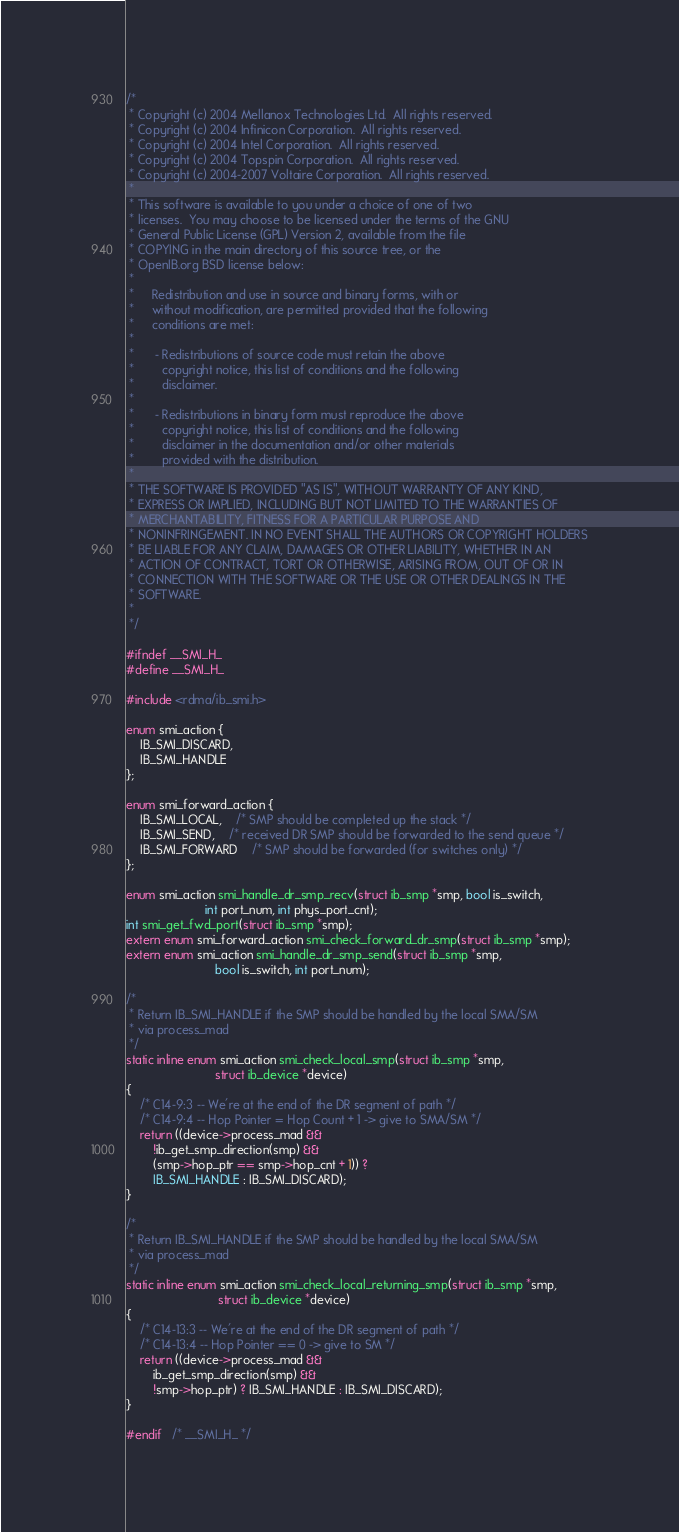Convert code to text. <code><loc_0><loc_0><loc_500><loc_500><_C_>/*
 * Copyright (c) 2004 Mellanox Technologies Ltd.  All rights reserved.
 * Copyright (c) 2004 Infinicon Corporation.  All rights reserved.
 * Copyright (c) 2004 Intel Corporation.  All rights reserved.
 * Copyright (c) 2004 Topspin Corporation.  All rights reserved.
 * Copyright (c) 2004-2007 Voltaire Corporation.  All rights reserved.
 *
 * This software is available to you under a choice of one of two
 * licenses.  You may choose to be licensed under the terms of the GNU
 * General Public License (GPL) Version 2, available from the file
 * COPYING in the main directory of this source tree, or the
 * OpenIB.org BSD license below:
 *
 *     Redistribution and use in source and binary forms, with or
 *     without modification, are permitted provided that the following
 *     conditions are met:
 *
 *      - Redistributions of source code must retain the above
 *        copyright notice, this list of conditions and the following
 *        disclaimer.
 *
 *      - Redistributions in binary form must reproduce the above
 *        copyright notice, this list of conditions and the following
 *        disclaimer in the documentation and/or other materials
 *        provided with the distribution.
 *
 * THE SOFTWARE IS PROVIDED "AS IS", WITHOUT WARRANTY OF ANY KIND,
 * EXPRESS OR IMPLIED, INCLUDING BUT NOT LIMITED TO THE WARRANTIES OF
 * MERCHANTABILITY, FITNESS FOR A PARTICULAR PURPOSE AND
 * NONINFRINGEMENT. IN NO EVENT SHALL THE AUTHORS OR COPYRIGHT HOLDERS
 * BE LIABLE FOR ANY CLAIM, DAMAGES OR OTHER LIABILITY, WHETHER IN AN
 * ACTION OF CONTRACT, TORT OR OTHERWISE, ARISING FROM, OUT OF OR IN
 * CONNECTION WITH THE SOFTWARE OR THE USE OR OTHER DEALINGS IN THE
 * SOFTWARE.
 *
 */

#ifndef __SMI_H_
#define __SMI_H_

#include <rdma/ib_smi.h>

enum smi_action {
	IB_SMI_DISCARD,
	IB_SMI_HANDLE
};

enum smi_forward_action {
	IB_SMI_LOCAL,	/* SMP should be completed up the stack */
	IB_SMI_SEND,	/* received DR SMP should be forwarded to the send queue */
	IB_SMI_FORWARD	/* SMP should be forwarded (for switches only) */
};

enum smi_action smi_handle_dr_smp_recv(struct ib_smp *smp, bool is_switch,
				       int port_num, int phys_port_cnt);
int smi_get_fwd_port(struct ib_smp *smp);
extern enum smi_forward_action smi_check_forward_dr_smp(struct ib_smp *smp);
extern enum smi_action smi_handle_dr_smp_send(struct ib_smp *smp,
					      bool is_switch, int port_num);

/*
 * Return IB_SMI_HANDLE if the SMP should be handled by the local SMA/SM
 * via process_mad
 */
static inline enum smi_action smi_check_local_smp(struct ib_smp *smp,
						  struct ib_device *device)
{
	/* C14-9:3 -- We're at the end of the DR segment of path */
	/* C14-9:4 -- Hop Pointer = Hop Count + 1 -> give to SMA/SM */
	return ((device->process_mad &&
		!ib_get_smp_direction(smp) &&
		(smp->hop_ptr == smp->hop_cnt + 1)) ?
		IB_SMI_HANDLE : IB_SMI_DISCARD);
}

/*
 * Return IB_SMI_HANDLE if the SMP should be handled by the local SMA/SM
 * via process_mad
 */
static inline enum smi_action smi_check_local_returning_smp(struct ib_smp *smp,
						   struct ib_device *device)
{
	/* C14-13:3 -- We're at the end of the DR segment of path */
	/* C14-13:4 -- Hop Pointer == 0 -> give to SM */
	return ((device->process_mad &&
		ib_get_smp_direction(smp) &&
		!smp->hop_ptr) ? IB_SMI_HANDLE : IB_SMI_DISCARD);
}

#endif	/* __SMI_H_ */
</code> 